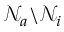<formula> <loc_0><loc_0><loc_500><loc_500>\mathcal { N } _ { a } \ \mathcal { N } _ { i }</formula> 